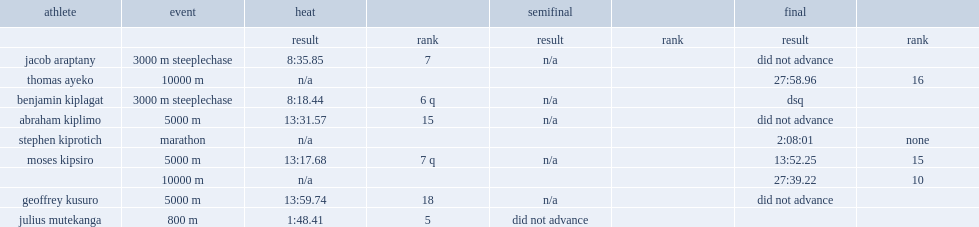In uganda at the 2012 summer olympics, which place did kusuro finish in the heat of the 5000 m event? 18.0. In uganda at the 2012 summer olympics, kusuro finished 18th in the heat of the 5000 m event, what was a time of? 13:59.74. 